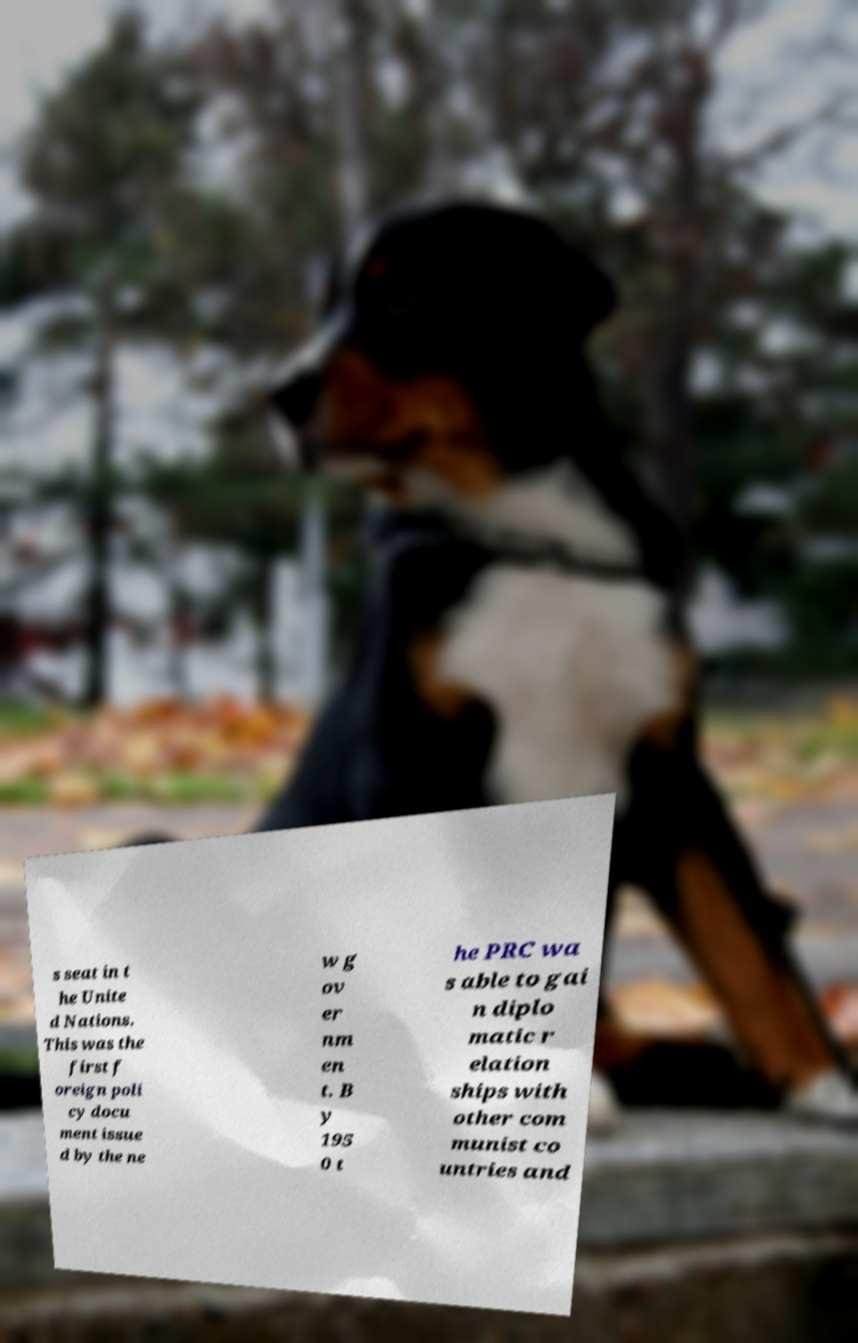What messages or text are displayed in this image? I need them in a readable, typed format. s seat in t he Unite d Nations. This was the first f oreign poli cy docu ment issue d by the ne w g ov er nm en t. B y 195 0 t he PRC wa s able to gai n diplo matic r elation ships with other com munist co untries and 